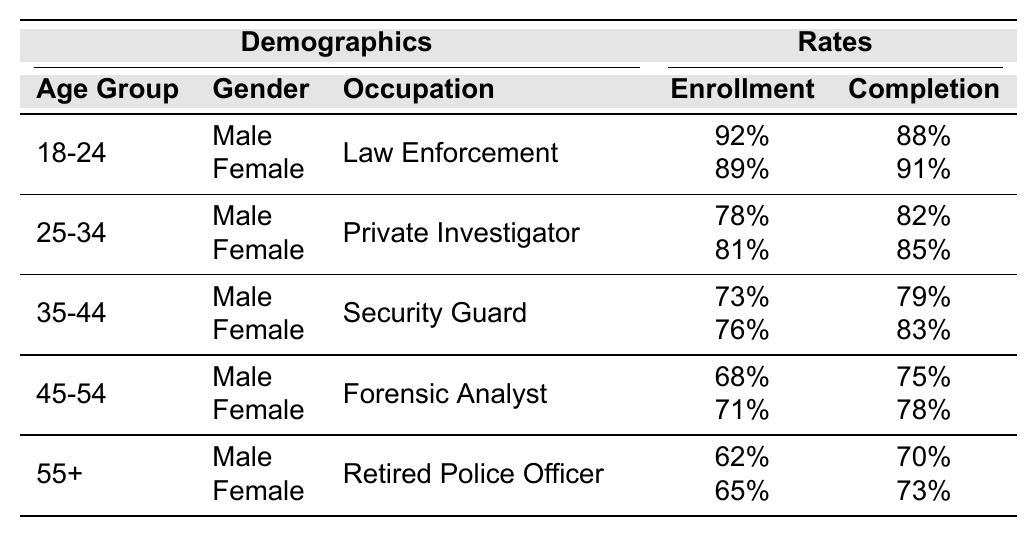What is the enrollment rate for females aged 35-44 in the Security Guard occupation? According to the table, the enrollment rate for females in the 35-44 age group and in the Security Guard occupation is listed as 76%.
Answer: 76% What is the completion rate for males aged 45-54 who are Forensic Analysts? The completion rate for males aged 45-54 in the Forensic Analyst occupation is 75%, as shown in the table.
Answer: 75% Which age group has the highest enrollment rate for females? By comparing the enrollment rates for females across age groups, the highest rate is 89% for females aged 18-24.
Answer: 18-24 How does the completion rate for males aged 25-34 compare to males aged 35-44? The completion rate for males aged 25-34 is 82%, while for males aged 35-44 it is 79%. The difference in completion rates is 3%, meaning younger males have a higher completion rate.
Answer: Higher by 3% What is the average enrollment rate for the 55+ age group? The enrollment rates for the 55+ age group are 62% for males and 65% for females. The average is calculated as (62 + 65) / 2 = 63.5%.
Answer: 63.5% Is the completion rate for female Private Investigators higher than that for female Law Enforcement officers? The completion rate for female Private Investigators is 85%, while for female Law Enforcement officers it is 91%. Therefore, the statement is false.
Answer: No What is the combined enrollment rate for males and females aged 25-34? The enrollment rates for 25-34 age group are 78% for males and 81% for females. The combined enrollment rate is (78 + 81) / 2 = 79.5% since we consider both genders equally.
Answer: 79.5% In which occupation do females have the lowest completion rate among the major age groups? The table shows that female Forensic Analysts aged 45-54 have a completion rate of 78%, which is the lowest among the female completion rates listed.
Answer: Forensic Analyst (45-54) How do the enrollment rates for males in the 18-24 age group compare with those in the 55+ age group? The enrollment rate for males aged 18-24 is 92%, while for males aged 55+ it is 62%. The difference is 30%, indicating that younger males have a significantly higher enrollment rate.
Answer: 30% higher for 18-24 What is the difference in completion rates between male and female law enforcement officers aged 18-24? The completion rate for male law enforcement officers aged 18-24 is 88%, while for females it is 91%. Therefore, female officers have a higher completion rate by 3%.
Answer: 3% higher for females 